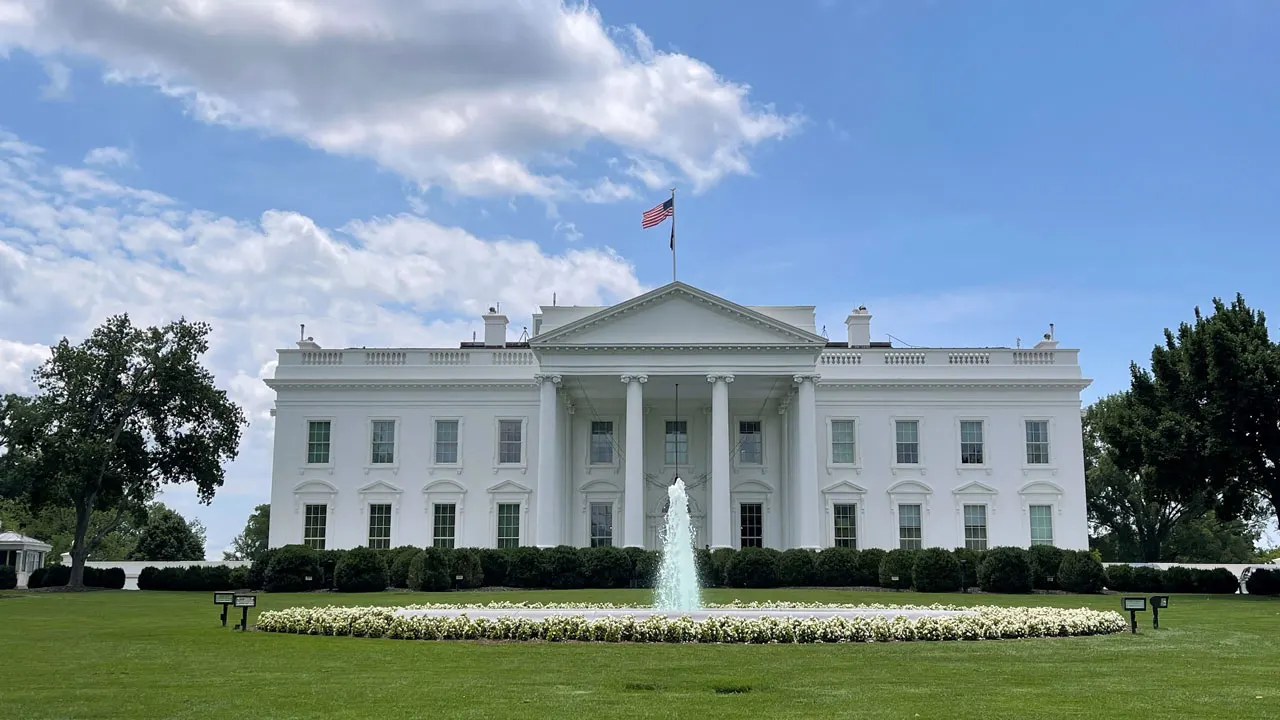Paint a vivid picture of what the South Lawn of the White House looks like during a major event. During a major event, the South Lawn of the White House transforms into a hub of activity and splendor. Imagine rows of elegantly set tables under large white tents, adorned with fine china, crystal glassware, and beautiful floral arrangements. The lawn is filled with the hum of conversation and laughter, as guests from different walks of life gather to celebrate or mark an important occasion. Twinkling string lights and lanterns create a magical ambiance as dusk falls, casting a warm glow over the scene. The majestic fountain at the center of the lawn adds a touch of grace, its waters dancing in the light. Uniformed staff move gracefully among the guests, serving delectable dishes and refreshing beverages. The American flag flies proudly above, symbolizing the unity and spirit of the nation. As the event progresses, live music fills the air, perhaps from a prestigious band or orchestra, culminating in a memorable evening under the stars.  What might you see on a quiet morning on the White House grounds? On a quiet morning on the White House grounds, you might see the dew-laden grass glistening in the soft morning light. The air is crisp and fresh, filled with the gentle chirping of birds. The peacefulness is almost palpable as the first rays of sunlight bathe the iconic building in a golden hue. Gardeners could be seen tending to the lush flowerbeds, carefully pruning and watering the plants. Occasional, soft footsteps of early risers - perhaps a staff member or a family dog out for a stroll - add to the serene atmosphere. The fountain on the front lawn quietly bubbles away, its rhythmic sounds blending seamlessly with the tranquility. The American flag flutters gently in the breeze, a solitary symbol of the nation's enduring strength in the quiet dawn. 